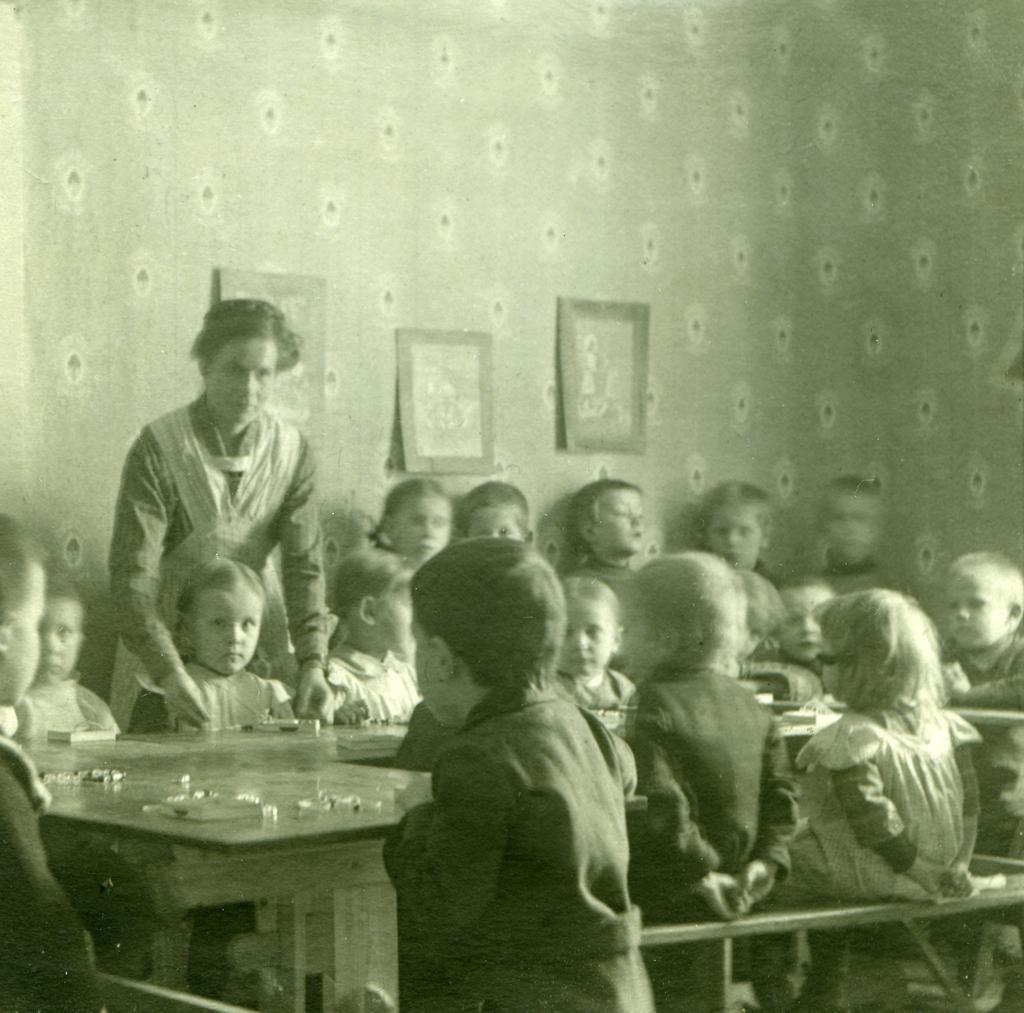In one or two sentences, can you explain what this image depicts? In this image we can see many children are sitting around the table. 